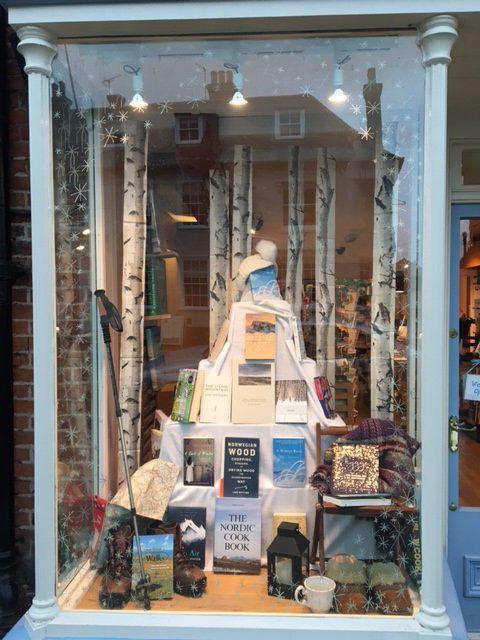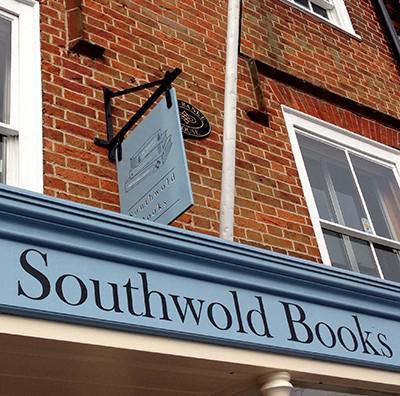The first image is the image on the left, the second image is the image on the right. Examine the images to the left and right. Is the description "There is an open door between two display windows of a shelf of books and at the bottom there a blue bricks." accurate? Answer yes or no. No. The first image is the image on the left, the second image is the image on the right. Examine the images to the left and right. Is the description "The bookstore on the right has a banner of pennants in different shades of blue." accurate? Answer yes or no. No. 